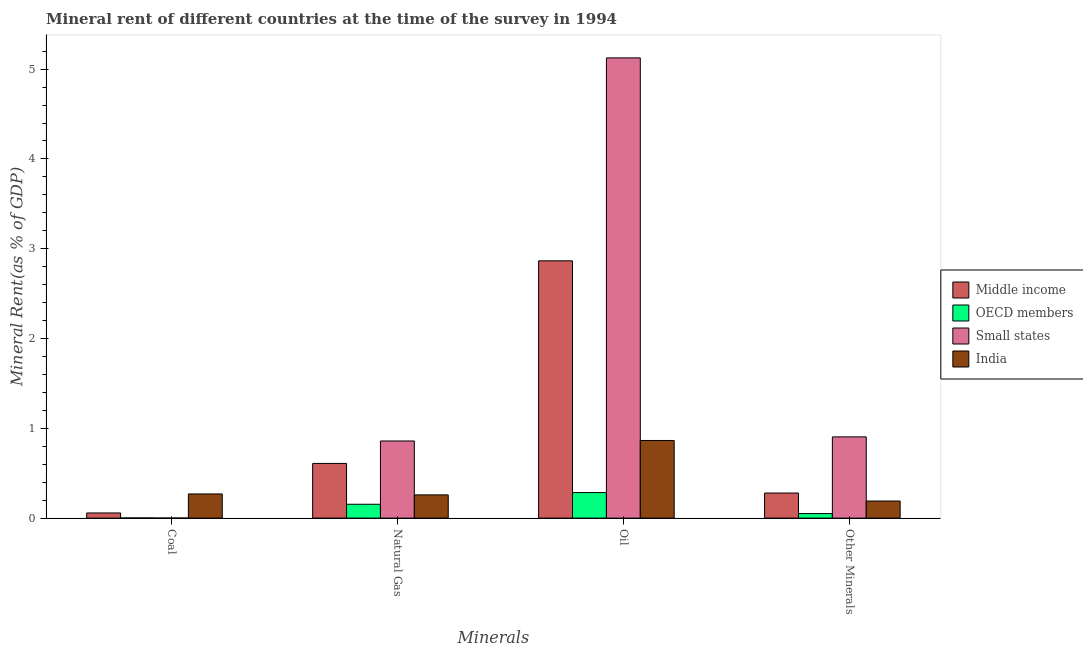How many different coloured bars are there?
Provide a short and direct response. 4. Are the number of bars per tick equal to the number of legend labels?
Your answer should be very brief. Yes. What is the label of the 3rd group of bars from the left?
Your answer should be very brief. Oil. What is the coal rent in India?
Your answer should be compact. 0.27. Across all countries, what is the maximum natural gas rent?
Your response must be concise. 0.86. Across all countries, what is the minimum oil rent?
Keep it short and to the point. 0.28. In which country was the oil rent maximum?
Your answer should be compact. Small states. In which country was the coal rent minimum?
Offer a terse response. Small states. What is the total coal rent in the graph?
Give a very brief answer. 0.33. What is the difference between the oil rent in Small states and that in OECD members?
Your answer should be very brief. 4.84. What is the difference between the coal rent in OECD members and the  rent of other minerals in India?
Offer a very short reply. -0.19. What is the average  rent of other minerals per country?
Make the answer very short. 0.36. What is the difference between the oil rent and  rent of other minerals in Small states?
Offer a terse response. 4.22. What is the ratio of the natural gas rent in OECD members to that in Small states?
Give a very brief answer. 0.18. Is the  rent of other minerals in Middle income less than that in India?
Make the answer very short. No. Is the difference between the natural gas rent in India and Small states greater than the difference between the oil rent in India and Small states?
Offer a terse response. Yes. What is the difference between the highest and the second highest natural gas rent?
Keep it short and to the point. 0.25. What is the difference between the highest and the lowest oil rent?
Offer a terse response. 4.84. In how many countries, is the coal rent greater than the average coal rent taken over all countries?
Give a very brief answer. 1. Is it the case that in every country, the sum of the coal rent and natural gas rent is greater than the sum of oil rent and  rent of other minerals?
Offer a terse response. No. What does the 3rd bar from the left in Coal represents?
Offer a terse response. Small states. What is the difference between two consecutive major ticks on the Y-axis?
Your response must be concise. 1. Are the values on the major ticks of Y-axis written in scientific E-notation?
Keep it short and to the point. No. Does the graph contain grids?
Make the answer very short. No. How many legend labels are there?
Your answer should be very brief. 4. What is the title of the graph?
Offer a very short reply. Mineral rent of different countries at the time of the survey in 1994. Does "Angola" appear as one of the legend labels in the graph?
Your response must be concise. No. What is the label or title of the X-axis?
Ensure brevity in your answer.  Minerals. What is the label or title of the Y-axis?
Your response must be concise. Mineral Rent(as % of GDP). What is the Mineral Rent(as % of GDP) of Middle income in Coal?
Provide a succinct answer. 0.06. What is the Mineral Rent(as % of GDP) in OECD members in Coal?
Keep it short and to the point. 0. What is the Mineral Rent(as % of GDP) in Small states in Coal?
Your response must be concise. 0. What is the Mineral Rent(as % of GDP) of India in Coal?
Provide a succinct answer. 0.27. What is the Mineral Rent(as % of GDP) in Middle income in Natural Gas?
Your answer should be very brief. 0.61. What is the Mineral Rent(as % of GDP) in OECD members in Natural Gas?
Your answer should be very brief. 0.15. What is the Mineral Rent(as % of GDP) of Small states in Natural Gas?
Your response must be concise. 0.86. What is the Mineral Rent(as % of GDP) of India in Natural Gas?
Your answer should be very brief. 0.26. What is the Mineral Rent(as % of GDP) of Middle income in Oil?
Ensure brevity in your answer.  2.87. What is the Mineral Rent(as % of GDP) of OECD members in Oil?
Provide a short and direct response. 0.28. What is the Mineral Rent(as % of GDP) in Small states in Oil?
Offer a terse response. 5.13. What is the Mineral Rent(as % of GDP) in India in Oil?
Offer a very short reply. 0.86. What is the Mineral Rent(as % of GDP) in Middle income in Other Minerals?
Your answer should be very brief. 0.28. What is the Mineral Rent(as % of GDP) in OECD members in Other Minerals?
Provide a short and direct response. 0.05. What is the Mineral Rent(as % of GDP) of Small states in Other Minerals?
Offer a very short reply. 0.9. What is the Mineral Rent(as % of GDP) in India in Other Minerals?
Ensure brevity in your answer.  0.19. Across all Minerals, what is the maximum Mineral Rent(as % of GDP) in Middle income?
Ensure brevity in your answer.  2.87. Across all Minerals, what is the maximum Mineral Rent(as % of GDP) in OECD members?
Your response must be concise. 0.28. Across all Minerals, what is the maximum Mineral Rent(as % of GDP) in Small states?
Ensure brevity in your answer.  5.13. Across all Minerals, what is the maximum Mineral Rent(as % of GDP) of India?
Make the answer very short. 0.86. Across all Minerals, what is the minimum Mineral Rent(as % of GDP) in Middle income?
Ensure brevity in your answer.  0.06. Across all Minerals, what is the minimum Mineral Rent(as % of GDP) in OECD members?
Provide a succinct answer. 0. Across all Minerals, what is the minimum Mineral Rent(as % of GDP) in Small states?
Your answer should be compact. 0. Across all Minerals, what is the minimum Mineral Rent(as % of GDP) of India?
Give a very brief answer. 0.19. What is the total Mineral Rent(as % of GDP) in Middle income in the graph?
Keep it short and to the point. 3.81. What is the total Mineral Rent(as % of GDP) in OECD members in the graph?
Provide a short and direct response. 0.49. What is the total Mineral Rent(as % of GDP) of Small states in the graph?
Ensure brevity in your answer.  6.89. What is the total Mineral Rent(as % of GDP) in India in the graph?
Keep it short and to the point. 1.58. What is the difference between the Mineral Rent(as % of GDP) in Middle income in Coal and that in Natural Gas?
Your answer should be very brief. -0.55. What is the difference between the Mineral Rent(as % of GDP) of OECD members in Coal and that in Natural Gas?
Keep it short and to the point. -0.15. What is the difference between the Mineral Rent(as % of GDP) in Small states in Coal and that in Natural Gas?
Keep it short and to the point. -0.86. What is the difference between the Mineral Rent(as % of GDP) in India in Coal and that in Natural Gas?
Ensure brevity in your answer.  0.01. What is the difference between the Mineral Rent(as % of GDP) of Middle income in Coal and that in Oil?
Your response must be concise. -2.81. What is the difference between the Mineral Rent(as % of GDP) in OECD members in Coal and that in Oil?
Ensure brevity in your answer.  -0.28. What is the difference between the Mineral Rent(as % of GDP) in Small states in Coal and that in Oil?
Your answer should be very brief. -5.12. What is the difference between the Mineral Rent(as % of GDP) of India in Coal and that in Oil?
Your answer should be compact. -0.6. What is the difference between the Mineral Rent(as % of GDP) in Middle income in Coal and that in Other Minerals?
Ensure brevity in your answer.  -0.22. What is the difference between the Mineral Rent(as % of GDP) of OECD members in Coal and that in Other Minerals?
Provide a succinct answer. -0.05. What is the difference between the Mineral Rent(as % of GDP) of Small states in Coal and that in Other Minerals?
Give a very brief answer. -0.9. What is the difference between the Mineral Rent(as % of GDP) of India in Coal and that in Other Minerals?
Ensure brevity in your answer.  0.08. What is the difference between the Mineral Rent(as % of GDP) of Middle income in Natural Gas and that in Oil?
Provide a succinct answer. -2.26. What is the difference between the Mineral Rent(as % of GDP) in OECD members in Natural Gas and that in Oil?
Give a very brief answer. -0.13. What is the difference between the Mineral Rent(as % of GDP) of Small states in Natural Gas and that in Oil?
Your answer should be compact. -4.27. What is the difference between the Mineral Rent(as % of GDP) in India in Natural Gas and that in Oil?
Your answer should be compact. -0.61. What is the difference between the Mineral Rent(as % of GDP) in Middle income in Natural Gas and that in Other Minerals?
Give a very brief answer. 0.33. What is the difference between the Mineral Rent(as % of GDP) in OECD members in Natural Gas and that in Other Minerals?
Give a very brief answer. 0.1. What is the difference between the Mineral Rent(as % of GDP) in Small states in Natural Gas and that in Other Minerals?
Offer a terse response. -0.05. What is the difference between the Mineral Rent(as % of GDP) in India in Natural Gas and that in Other Minerals?
Provide a short and direct response. 0.07. What is the difference between the Mineral Rent(as % of GDP) in Middle income in Oil and that in Other Minerals?
Your answer should be compact. 2.59. What is the difference between the Mineral Rent(as % of GDP) of OECD members in Oil and that in Other Minerals?
Keep it short and to the point. 0.23. What is the difference between the Mineral Rent(as % of GDP) in Small states in Oil and that in Other Minerals?
Your response must be concise. 4.22. What is the difference between the Mineral Rent(as % of GDP) in India in Oil and that in Other Minerals?
Ensure brevity in your answer.  0.67. What is the difference between the Mineral Rent(as % of GDP) in Middle income in Coal and the Mineral Rent(as % of GDP) in OECD members in Natural Gas?
Provide a succinct answer. -0.1. What is the difference between the Mineral Rent(as % of GDP) in Middle income in Coal and the Mineral Rent(as % of GDP) in Small states in Natural Gas?
Ensure brevity in your answer.  -0.8. What is the difference between the Mineral Rent(as % of GDP) of Middle income in Coal and the Mineral Rent(as % of GDP) of India in Natural Gas?
Keep it short and to the point. -0.2. What is the difference between the Mineral Rent(as % of GDP) of OECD members in Coal and the Mineral Rent(as % of GDP) of Small states in Natural Gas?
Your answer should be very brief. -0.86. What is the difference between the Mineral Rent(as % of GDP) in OECD members in Coal and the Mineral Rent(as % of GDP) in India in Natural Gas?
Your response must be concise. -0.26. What is the difference between the Mineral Rent(as % of GDP) in Small states in Coal and the Mineral Rent(as % of GDP) in India in Natural Gas?
Provide a short and direct response. -0.26. What is the difference between the Mineral Rent(as % of GDP) of Middle income in Coal and the Mineral Rent(as % of GDP) of OECD members in Oil?
Provide a short and direct response. -0.23. What is the difference between the Mineral Rent(as % of GDP) of Middle income in Coal and the Mineral Rent(as % of GDP) of Small states in Oil?
Ensure brevity in your answer.  -5.07. What is the difference between the Mineral Rent(as % of GDP) in Middle income in Coal and the Mineral Rent(as % of GDP) in India in Oil?
Ensure brevity in your answer.  -0.81. What is the difference between the Mineral Rent(as % of GDP) in OECD members in Coal and the Mineral Rent(as % of GDP) in Small states in Oil?
Your answer should be very brief. -5.12. What is the difference between the Mineral Rent(as % of GDP) of OECD members in Coal and the Mineral Rent(as % of GDP) of India in Oil?
Offer a terse response. -0.86. What is the difference between the Mineral Rent(as % of GDP) of Small states in Coal and the Mineral Rent(as % of GDP) of India in Oil?
Your response must be concise. -0.86. What is the difference between the Mineral Rent(as % of GDP) in Middle income in Coal and the Mineral Rent(as % of GDP) in OECD members in Other Minerals?
Your answer should be very brief. 0.01. What is the difference between the Mineral Rent(as % of GDP) in Middle income in Coal and the Mineral Rent(as % of GDP) in Small states in Other Minerals?
Make the answer very short. -0.85. What is the difference between the Mineral Rent(as % of GDP) of Middle income in Coal and the Mineral Rent(as % of GDP) of India in Other Minerals?
Offer a very short reply. -0.13. What is the difference between the Mineral Rent(as % of GDP) in OECD members in Coal and the Mineral Rent(as % of GDP) in Small states in Other Minerals?
Provide a short and direct response. -0.9. What is the difference between the Mineral Rent(as % of GDP) of OECD members in Coal and the Mineral Rent(as % of GDP) of India in Other Minerals?
Ensure brevity in your answer.  -0.19. What is the difference between the Mineral Rent(as % of GDP) in Small states in Coal and the Mineral Rent(as % of GDP) in India in Other Minerals?
Your answer should be very brief. -0.19. What is the difference between the Mineral Rent(as % of GDP) in Middle income in Natural Gas and the Mineral Rent(as % of GDP) in OECD members in Oil?
Your response must be concise. 0.32. What is the difference between the Mineral Rent(as % of GDP) in Middle income in Natural Gas and the Mineral Rent(as % of GDP) in Small states in Oil?
Provide a short and direct response. -4.52. What is the difference between the Mineral Rent(as % of GDP) in Middle income in Natural Gas and the Mineral Rent(as % of GDP) in India in Oil?
Keep it short and to the point. -0.26. What is the difference between the Mineral Rent(as % of GDP) of OECD members in Natural Gas and the Mineral Rent(as % of GDP) of Small states in Oil?
Ensure brevity in your answer.  -4.97. What is the difference between the Mineral Rent(as % of GDP) in OECD members in Natural Gas and the Mineral Rent(as % of GDP) in India in Oil?
Ensure brevity in your answer.  -0.71. What is the difference between the Mineral Rent(as % of GDP) in Small states in Natural Gas and the Mineral Rent(as % of GDP) in India in Oil?
Your response must be concise. -0.01. What is the difference between the Mineral Rent(as % of GDP) in Middle income in Natural Gas and the Mineral Rent(as % of GDP) in OECD members in Other Minerals?
Ensure brevity in your answer.  0.56. What is the difference between the Mineral Rent(as % of GDP) of Middle income in Natural Gas and the Mineral Rent(as % of GDP) of Small states in Other Minerals?
Provide a short and direct response. -0.3. What is the difference between the Mineral Rent(as % of GDP) in Middle income in Natural Gas and the Mineral Rent(as % of GDP) in India in Other Minerals?
Ensure brevity in your answer.  0.42. What is the difference between the Mineral Rent(as % of GDP) in OECD members in Natural Gas and the Mineral Rent(as % of GDP) in Small states in Other Minerals?
Ensure brevity in your answer.  -0.75. What is the difference between the Mineral Rent(as % of GDP) in OECD members in Natural Gas and the Mineral Rent(as % of GDP) in India in Other Minerals?
Your answer should be compact. -0.04. What is the difference between the Mineral Rent(as % of GDP) in Small states in Natural Gas and the Mineral Rent(as % of GDP) in India in Other Minerals?
Your response must be concise. 0.67. What is the difference between the Mineral Rent(as % of GDP) in Middle income in Oil and the Mineral Rent(as % of GDP) in OECD members in Other Minerals?
Your response must be concise. 2.81. What is the difference between the Mineral Rent(as % of GDP) in Middle income in Oil and the Mineral Rent(as % of GDP) in Small states in Other Minerals?
Ensure brevity in your answer.  1.96. What is the difference between the Mineral Rent(as % of GDP) of Middle income in Oil and the Mineral Rent(as % of GDP) of India in Other Minerals?
Offer a terse response. 2.67. What is the difference between the Mineral Rent(as % of GDP) in OECD members in Oil and the Mineral Rent(as % of GDP) in Small states in Other Minerals?
Your answer should be very brief. -0.62. What is the difference between the Mineral Rent(as % of GDP) in OECD members in Oil and the Mineral Rent(as % of GDP) in India in Other Minerals?
Offer a terse response. 0.09. What is the difference between the Mineral Rent(as % of GDP) of Small states in Oil and the Mineral Rent(as % of GDP) of India in Other Minerals?
Your response must be concise. 4.94. What is the average Mineral Rent(as % of GDP) of Middle income per Minerals?
Provide a succinct answer. 0.95. What is the average Mineral Rent(as % of GDP) in OECD members per Minerals?
Your response must be concise. 0.12. What is the average Mineral Rent(as % of GDP) in Small states per Minerals?
Give a very brief answer. 1.72. What is the average Mineral Rent(as % of GDP) in India per Minerals?
Your answer should be very brief. 0.4. What is the difference between the Mineral Rent(as % of GDP) in Middle income and Mineral Rent(as % of GDP) in OECD members in Coal?
Offer a very short reply. 0.06. What is the difference between the Mineral Rent(as % of GDP) in Middle income and Mineral Rent(as % of GDP) in Small states in Coal?
Ensure brevity in your answer.  0.06. What is the difference between the Mineral Rent(as % of GDP) in Middle income and Mineral Rent(as % of GDP) in India in Coal?
Your answer should be very brief. -0.21. What is the difference between the Mineral Rent(as % of GDP) of OECD members and Mineral Rent(as % of GDP) of Small states in Coal?
Offer a very short reply. 0. What is the difference between the Mineral Rent(as % of GDP) of OECD members and Mineral Rent(as % of GDP) of India in Coal?
Offer a terse response. -0.27. What is the difference between the Mineral Rent(as % of GDP) of Small states and Mineral Rent(as % of GDP) of India in Coal?
Ensure brevity in your answer.  -0.27. What is the difference between the Mineral Rent(as % of GDP) in Middle income and Mineral Rent(as % of GDP) in OECD members in Natural Gas?
Provide a succinct answer. 0.45. What is the difference between the Mineral Rent(as % of GDP) of Middle income and Mineral Rent(as % of GDP) of Small states in Natural Gas?
Provide a succinct answer. -0.25. What is the difference between the Mineral Rent(as % of GDP) in Middle income and Mineral Rent(as % of GDP) in India in Natural Gas?
Make the answer very short. 0.35. What is the difference between the Mineral Rent(as % of GDP) of OECD members and Mineral Rent(as % of GDP) of Small states in Natural Gas?
Provide a short and direct response. -0.7. What is the difference between the Mineral Rent(as % of GDP) of OECD members and Mineral Rent(as % of GDP) of India in Natural Gas?
Offer a very short reply. -0.1. What is the difference between the Mineral Rent(as % of GDP) in Small states and Mineral Rent(as % of GDP) in India in Natural Gas?
Your response must be concise. 0.6. What is the difference between the Mineral Rent(as % of GDP) in Middle income and Mineral Rent(as % of GDP) in OECD members in Oil?
Your response must be concise. 2.58. What is the difference between the Mineral Rent(as % of GDP) in Middle income and Mineral Rent(as % of GDP) in Small states in Oil?
Offer a very short reply. -2.26. What is the difference between the Mineral Rent(as % of GDP) in Middle income and Mineral Rent(as % of GDP) in India in Oil?
Your response must be concise. 2. What is the difference between the Mineral Rent(as % of GDP) in OECD members and Mineral Rent(as % of GDP) in Small states in Oil?
Your answer should be compact. -4.84. What is the difference between the Mineral Rent(as % of GDP) of OECD members and Mineral Rent(as % of GDP) of India in Oil?
Your answer should be compact. -0.58. What is the difference between the Mineral Rent(as % of GDP) of Small states and Mineral Rent(as % of GDP) of India in Oil?
Your answer should be compact. 4.26. What is the difference between the Mineral Rent(as % of GDP) in Middle income and Mineral Rent(as % of GDP) in OECD members in Other Minerals?
Your answer should be very brief. 0.23. What is the difference between the Mineral Rent(as % of GDP) in Middle income and Mineral Rent(as % of GDP) in Small states in Other Minerals?
Offer a terse response. -0.63. What is the difference between the Mineral Rent(as % of GDP) in Middle income and Mineral Rent(as % of GDP) in India in Other Minerals?
Make the answer very short. 0.09. What is the difference between the Mineral Rent(as % of GDP) of OECD members and Mineral Rent(as % of GDP) of Small states in Other Minerals?
Keep it short and to the point. -0.85. What is the difference between the Mineral Rent(as % of GDP) of OECD members and Mineral Rent(as % of GDP) of India in Other Minerals?
Give a very brief answer. -0.14. What is the difference between the Mineral Rent(as % of GDP) in Small states and Mineral Rent(as % of GDP) in India in Other Minerals?
Make the answer very short. 0.71. What is the ratio of the Mineral Rent(as % of GDP) of Middle income in Coal to that in Natural Gas?
Provide a succinct answer. 0.09. What is the ratio of the Mineral Rent(as % of GDP) of OECD members in Coal to that in Natural Gas?
Give a very brief answer. 0.01. What is the ratio of the Mineral Rent(as % of GDP) of Small states in Coal to that in Natural Gas?
Your answer should be very brief. 0. What is the ratio of the Mineral Rent(as % of GDP) of India in Coal to that in Natural Gas?
Offer a terse response. 1.04. What is the ratio of the Mineral Rent(as % of GDP) in OECD members in Coal to that in Oil?
Ensure brevity in your answer.  0.01. What is the ratio of the Mineral Rent(as % of GDP) in India in Coal to that in Oil?
Offer a terse response. 0.31. What is the ratio of the Mineral Rent(as % of GDP) in Middle income in Coal to that in Other Minerals?
Your response must be concise. 0.21. What is the ratio of the Mineral Rent(as % of GDP) in OECD members in Coal to that in Other Minerals?
Keep it short and to the point. 0.04. What is the ratio of the Mineral Rent(as % of GDP) in Small states in Coal to that in Other Minerals?
Provide a succinct answer. 0. What is the ratio of the Mineral Rent(as % of GDP) of India in Coal to that in Other Minerals?
Make the answer very short. 1.41. What is the ratio of the Mineral Rent(as % of GDP) of Middle income in Natural Gas to that in Oil?
Your response must be concise. 0.21. What is the ratio of the Mineral Rent(as % of GDP) in OECD members in Natural Gas to that in Oil?
Give a very brief answer. 0.54. What is the ratio of the Mineral Rent(as % of GDP) in Small states in Natural Gas to that in Oil?
Ensure brevity in your answer.  0.17. What is the ratio of the Mineral Rent(as % of GDP) of India in Natural Gas to that in Oil?
Give a very brief answer. 0.3. What is the ratio of the Mineral Rent(as % of GDP) of Middle income in Natural Gas to that in Other Minerals?
Keep it short and to the point. 2.18. What is the ratio of the Mineral Rent(as % of GDP) of OECD members in Natural Gas to that in Other Minerals?
Your response must be concise. 3.06. What is the ratio of the Mineral Rent(as % of GDP) of Small states in Natural Gas to that in Other Minerals?
Provide a short and direct response. 0.95. What is the ratio of the Mineral Rent(as % of GDP) in India in Natural Gas to that in Other Minerals?
Give a very brief answer. 1.36. What is the ratio of the Mineral Rent(as % of GDP) in Middle income in Oil to that in Other Minerals?
Your response must be concise. 10.25. What is the ratio of the Mineral Rent(as % of GDP) in OECD members in Oil to that in Other Minerals?
Your answer should be compact. 5.64. What is the ratio of the Mineral Rent(as % of GDP) in Small states in Oil to that in Other Minerals?
Give a very brief answer. 5.66. What is the ratio of the Mineral Rent(as % of GDP) in India in Oil to that in Other Minerals?
Offer a very short reply. 4.54. What is the difference between the highest and the second highest Mineral Rent(as % of GDP) in Middle income?
Your answer should be compact. 2.26. What is the difference between the highest and the second highest Mineral Rent(as % of GDP) of OECD members?
Provide a short and direct response. 0.13. What is the difference between the highest and the second highest Mineral Rent(as % of GDP) of Small states?
Give a very brief answer. 4.22. What is the difference between the highest and the second highest Mineral Rent(as % of GDP) of India?
Keep it short and to the point. 0.6. What is the difference between the highest and the lowest Mineral Rent(as % of GDP) in Middle income?
Your response must be concise. 2.81. What is the difference between the highest and the lowest Mineral Rent(as % of GDP) in OECD members?
Offer a very short reply. 0.28. What is the difference between the highest and the lowest Mineral Rent(as % of GDP) in Small states?
Provide a short and direct response. 5.12. What is the difference between the highest and the lowest Mineral Rent(as % of GDP) in India?
Offer a very short reply. 0.67. 